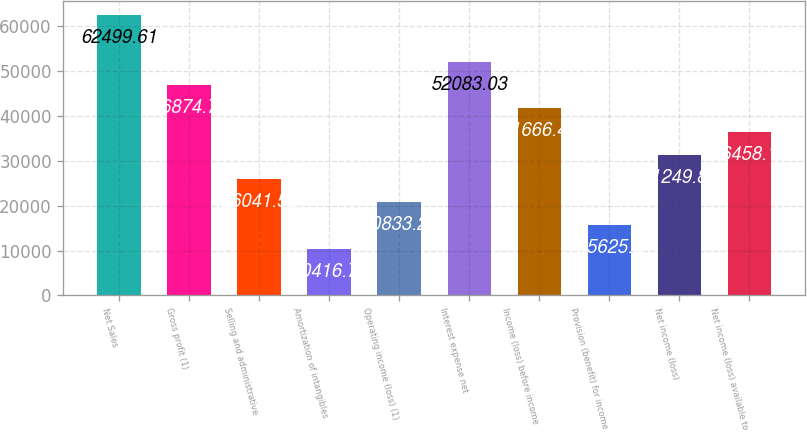Convert chart. <chart><loc_0><loc_0><loc_500><loc_500><bar_chart><fcel>Net Sales<fcel>Gross profit (1)<fcel>Selling and administrative<fcel>Amortization of intangibles<fcel>Operating income (loss) (1)<fcel>Interest expense net<fcel>Income (loss) before income<fcel>Provision (benefit) for income<fcel>Net income (loss)<fcel>Net income (loss) available to<nl><fcel>62499.6<fcel>46874.7<fcel>26041.6<fcel>10416.7<fcel>20833.3<fcel>52083<fcel>41666.4<fcel>15625<fcel>31249.9<fcel>36458.2<nl></chart> 